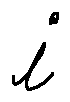<formula> <loc_0><loc_0><loc_500><loc_500>i</formula> 